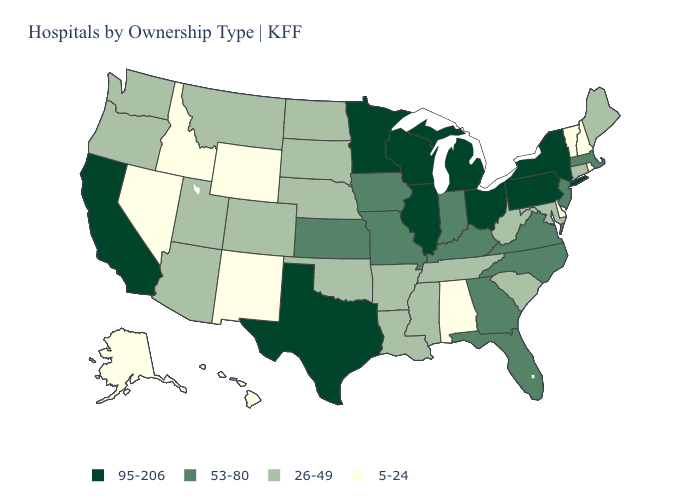What is the value of Louisiana?
Give a very brief answer. 26-49. Name the states that have a value in the range 53-80?
Concise answer only. Florida, Georgia, Indiana, Iowa, Kansas, Kentucky, Massachusetts, Missouri, New Jersey, North Carolina, Virginia. Name the states that have a value in the range 5-24?
Concise answer only. Alabama, Alaska, Delaware, Hawaii, Idaho, Nevada, New Hampshire, New Mexico, Rhode Island, Vermont, Wyoming. What is the lowest value in the MidWest?
Give a very brief answer. 26-49. Is the legend a continuous bar?
Answer briefly. No. How many symbols are there in the legend?
Be succinct. 4. Does the map have missing data?
Be succinct. No. Does Alabama have a lower value than Hawaii?
Answer briefly. No. Which states have the highest value in the USA?
Be succinct. California, Illinois, Michigan, Minnesota, New York, Ohio, Pennsylvania, Texas, Wisconsin. Name the states that have a value in the range 53-80?
Short answer required. Florida, Georgia, Indiana, Iowa, Kansas, Kentucky, Massachusetts, Missouri, New Jersey, North Carolina, Virginia. Does California have the highest value in the West?
Keep it brief. Yes. What is the value of Louisiana?
Concise answer only. 26-49. Among the states that border Pennsylvania , does Ohio have the highest value?
Keep it brief. Yes. Among the states that border New York , which have the highest value?
Quick response, please. Pennsylvania. What is the lowest value in states that border Texas?
Give a very brief answer. 5-24. 